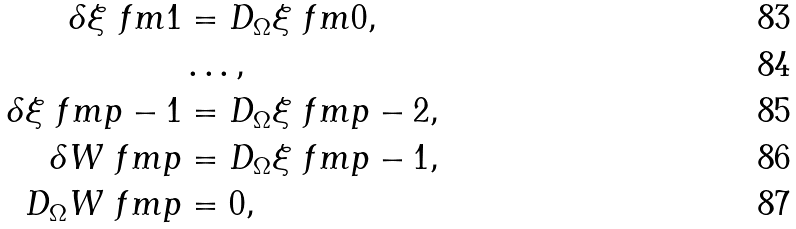<formula> <loc_0><loc_0><loc_500><loc_500>\delta \xi \ f m { 1 } & = D _ { \Omega } \xi \ f m { 0 } , \\ & \dots , \\ \delta \xi \ f m { p - 1 } & = D _ { \Omega } \xi \ f m { p - 2 } , \\ \delta W \ f m { p } & = D _ { \Omega } \xi \ f m { p - 1 } , \\ D _ { \Omega } W \ f m { p } & = 0 ,</formula> 